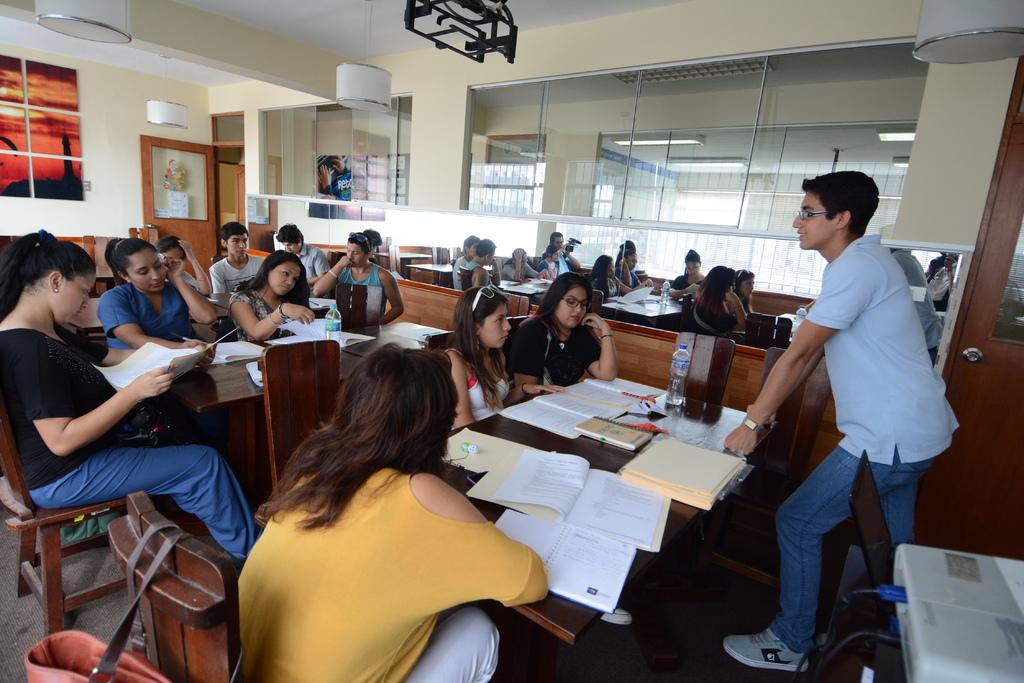What is happening in the image involving the group of people? The people in the image are seated on chairs. What objects are present on the table in the image? There are books and water bottles on the table. Is there anyone standing in the image? Yes, there is a person standing in the image. What might the standing person be doing? The standing person appears to be speaking. What type of butter is being used to quiet the plough in the image? There is no butter, quieting, or plough present in the image. 